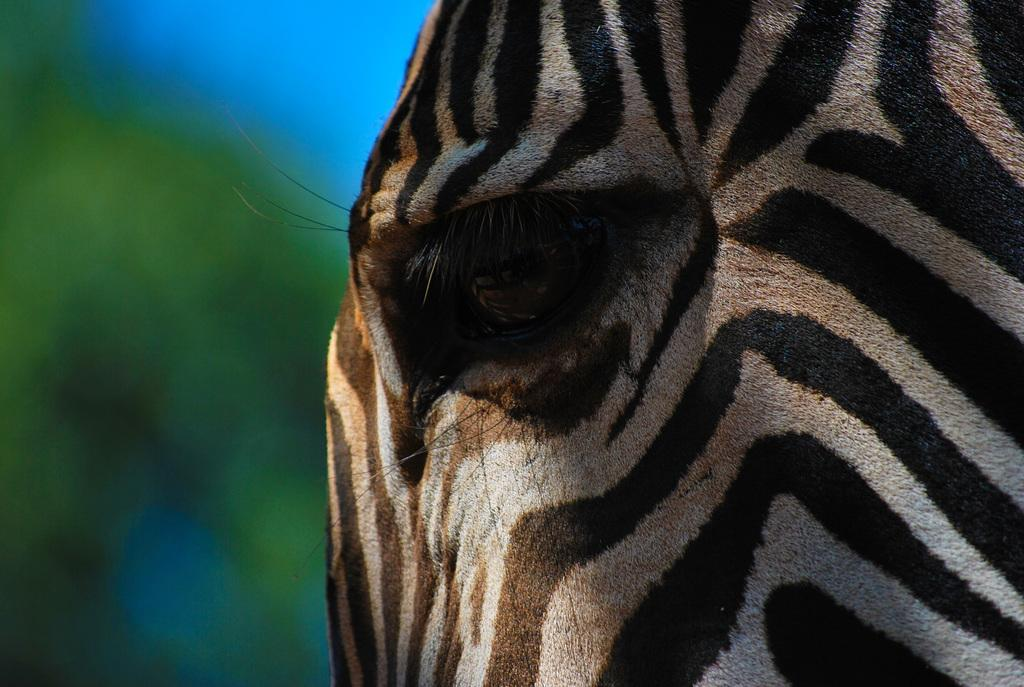What type of animal is in the image? There is a zebra in the image. What type of string can be seen hanging from the zebra's pocket in the image? There is no string or pocket present on the zebra in the image. 